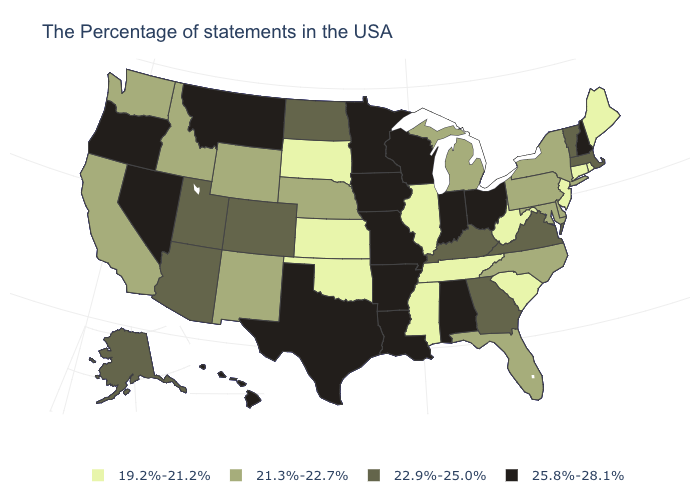Name the states that have a value in the range 21.3%-22.7%?
Short answer required. New York, Delaware, Maryland, Pennsylvania, North Carolina, Florida, Michigan, Nebraska, Wyoming, New Mexico, Idaho, California, Washington. What is the value of Maine?
Short answer required. 19.2%-21.2%. Does Massachusetts have the lowest value in the USA?
Quick response, please. No. What is the value of Rhode Island?
Write a very short answer. 19.2%-21.2%. Does Massachusetts have a lower value than Missouri?
Be succinct. Yes. Name the states that have a value in the range 22.9%-25.0%?
Keep it brief. Massachusetts, Vermont, Virginia, Georgia, Kentucky, North Dakota, Colorado, Utah, Arizona, Alaska. Does Iowa have the lowest value in the USA?
Be succinct. No. Name the states that have a value in the range 19.2%-21.2%?
Give a very brief answer. Maine, Rhode Island, Connecticut, New Jersey, South Carolina, West Virginia, Tennessee, Illinois, Mississippi, Kansas, Oklahoma, South Dakota. Does the first symbol in the legend represent the smallest category?
Be succinct. Yes. What is the value of Arizona?
Quick response, please. 22.9%-25.0%. Name the states that have a value in the range 21.3%-22.7%?
Give a very brief answer. New York, Delaware, Maryland, Pennsylvania, North Carolina, Florida, Michigan, Nebraska, Wyoming, New Mexico, Idaho, California, Washington. Name the states that have a value in the range 22.9%-25.0%?
Be succinct. Massachusetts, Vermont, Virginia, Georgia, Kentucky, North Dakota, Colorado, Utah, Arizona, Alaska. Name the states that have a value in the range 22.9%-25.0%?
Give a very brief answer. Massachusetts, Vermont, Virginia, Georgia, Kentucky, North Dakota, Colorado, Utah, Arizona, Alaska. Does the first symbol in the legend represent the smallest category?
Write a very short answer. Yes. What is the highest value in the South ?
Concise answer only. 25.8%-28.1%. 